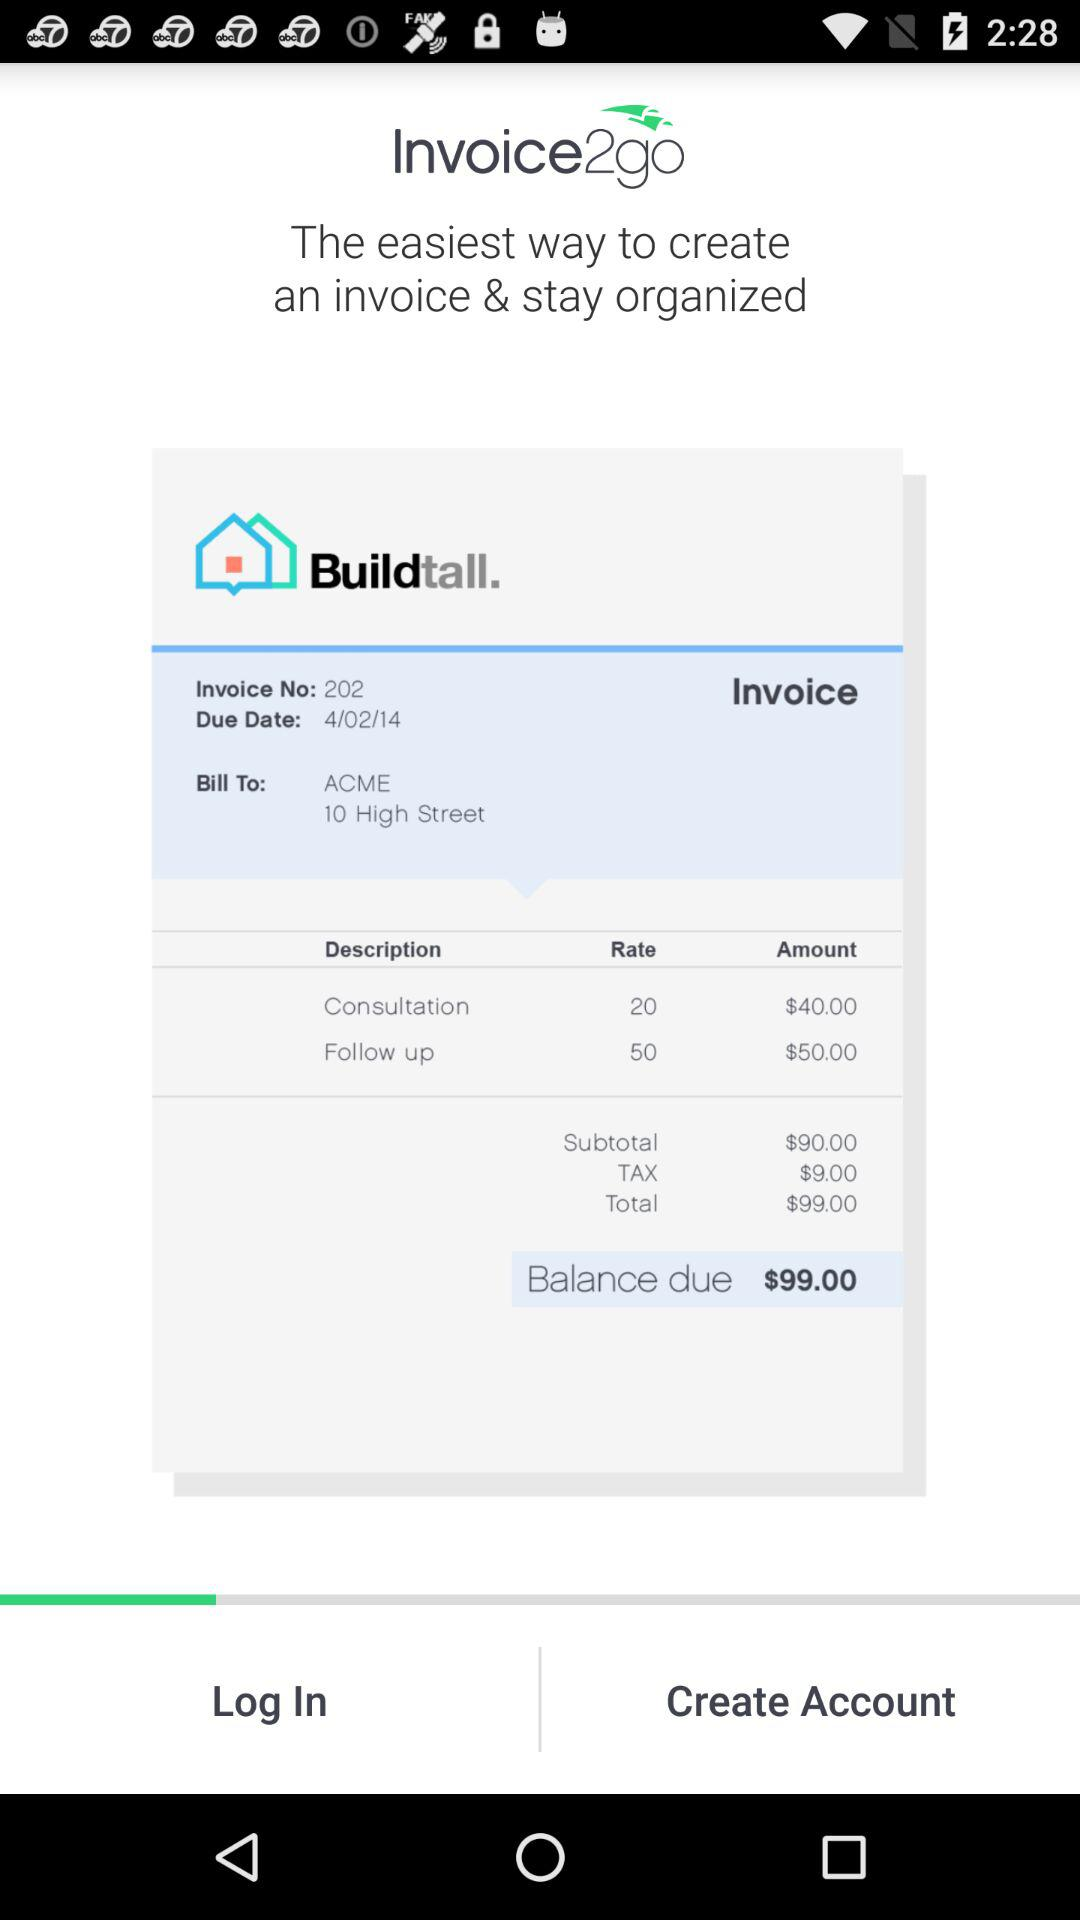What is the due date? The due date is 4/02/14. 